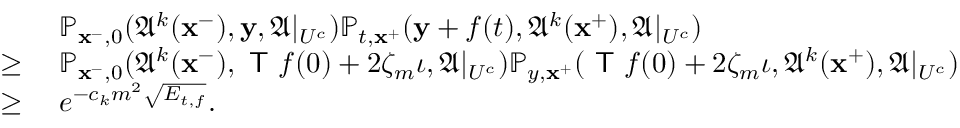Convert formula to latex. <formula><loc_0><loc_0><loc_500><loc_500>\begin{array} { r l } & { \mathbb { P } _ { x ^ { - } , 0 } ( \mathfrak { A } ^ { k } ( x ^ { - } ) , y , \mathfrak { A } | _ { U ^ { c } } ) \mathbb { P } _ { t , x ^ { + } } ( y + f ( t ) , \mathfrak { A } ^ { k } ( x ^ { + } ) , \mathfrak { A } | _ { U ^ { c } } ) } \\ { \geq \, } & { \mathbb { P } _ { x ^ { - } , 0 } ( \mathfrak { A } ^ { k } ( x ^ { - } ) , T f ( 0 ) + 2 \zeta _ { m } \iota , \mathfrak { A } | _ { U ^ { c } } ) \mathbb { P } _ { y , x ^ { + } } ( T f ( 0 ) + 2 \zeta _ { m } \iota , \mathfrak { A } ^ { k } ( x ^ { + } ) , \mathfrak { A } | _ { U ^ { c } } ) } \\ { \geq \, } & { e ^ { - c _ { k } m ^ { 2 } \sqrt { E _ { t , f } } } . } \end{array}</formula> 